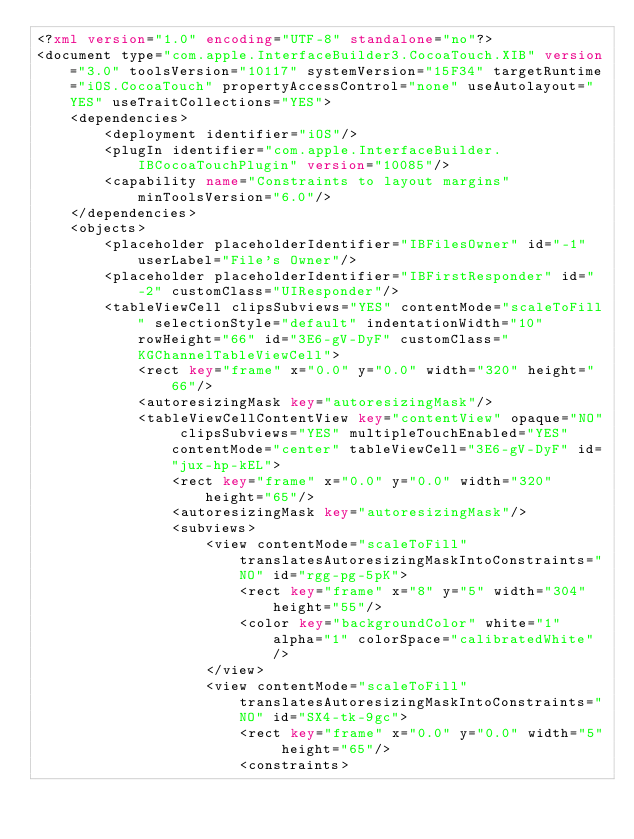Convert code to text. <code><loc_0><loc_0><loc_500><loc_500><_XML_><?xml version="1.0" encoding="UTF-8" standalone="no"?>
<document type="com.apple.InterfaceBuilder3.CocoaTouch.XIB" version="3.0" toolsVersion="10117" systemVersion="15F34" targetRuntime="iOS.CocoaTouch" propertyAccessControl="none" useAutolayout="YES" useTraitCollections="YES">
    <dependencies>
        <deployment identifier="iOS"/>
        <plugIn identifier="com.apple.InterfaceBuilder.IBCocoaTouchPlugin" version="10085"/>
        <capability name="Constraints to layout margins" minToolsVersion="6.0"/>
    </dependencies>
    <objects>
        <placeholder placeholderIdentifier="IBFilesOwner" id="-1" userLabel="File's Owner"/>
        <placeholder placeholderIdentifier="IBFirstResponder" id="-2" customClass="UIResponder"/>
        <tableViewCell clipsSubviews="YES" contentMode="scaleToFill" selectionStyle="default" indentationWidth="10" rowHeight="66" id="3E6-gV-DyF" customClass="KGChannelTableViewCell">
            <rect key="frame" x="0.0" y="0.0" width="320" height="66"/>
            <autoresizingMask key="autoresizingMask"/>
            <tableViewCellContentView key="contentView" opaque="NO" clipsSubviews="YES" multipleTouchEnabled="YES" contentMode="center" tableViewCell="3E6-gV-DyF" id="jux-hp-kEL">
                <rect key="frame" x="0.0" y="0.0" width="320" height="65"/>
                <autoresizingMask key="autoresizingMask"/>
                <subviews>
                    <view contentMode="scaleToFill" translatesAutoresizingMaskIntoConstraints="NO" id="rgg-pg-5pK">
                        <rect key="frame" x="8" y="5" width="304" height="55"/>
                        <color key="backgroundColor" white="1" alpha="1" colorSpace="calibratedWhite"/>
                    </view>
                    <view contentMode="scaleToFill" translatesAutoresizingMaskIntoConstraints="NO" id="SX4-tk-9gc">
                        <rect key="frame" x="0.0" y="0.0" width="5" height="65"/>
                        <constraints></code> 